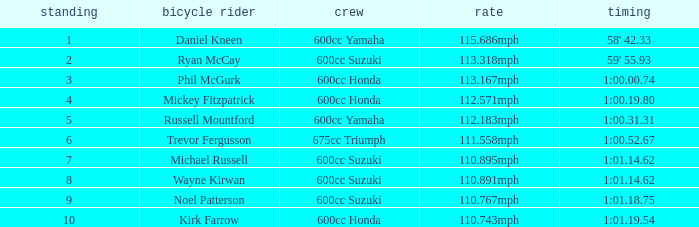How many ranks have michael russell as the rider? 7.0. 